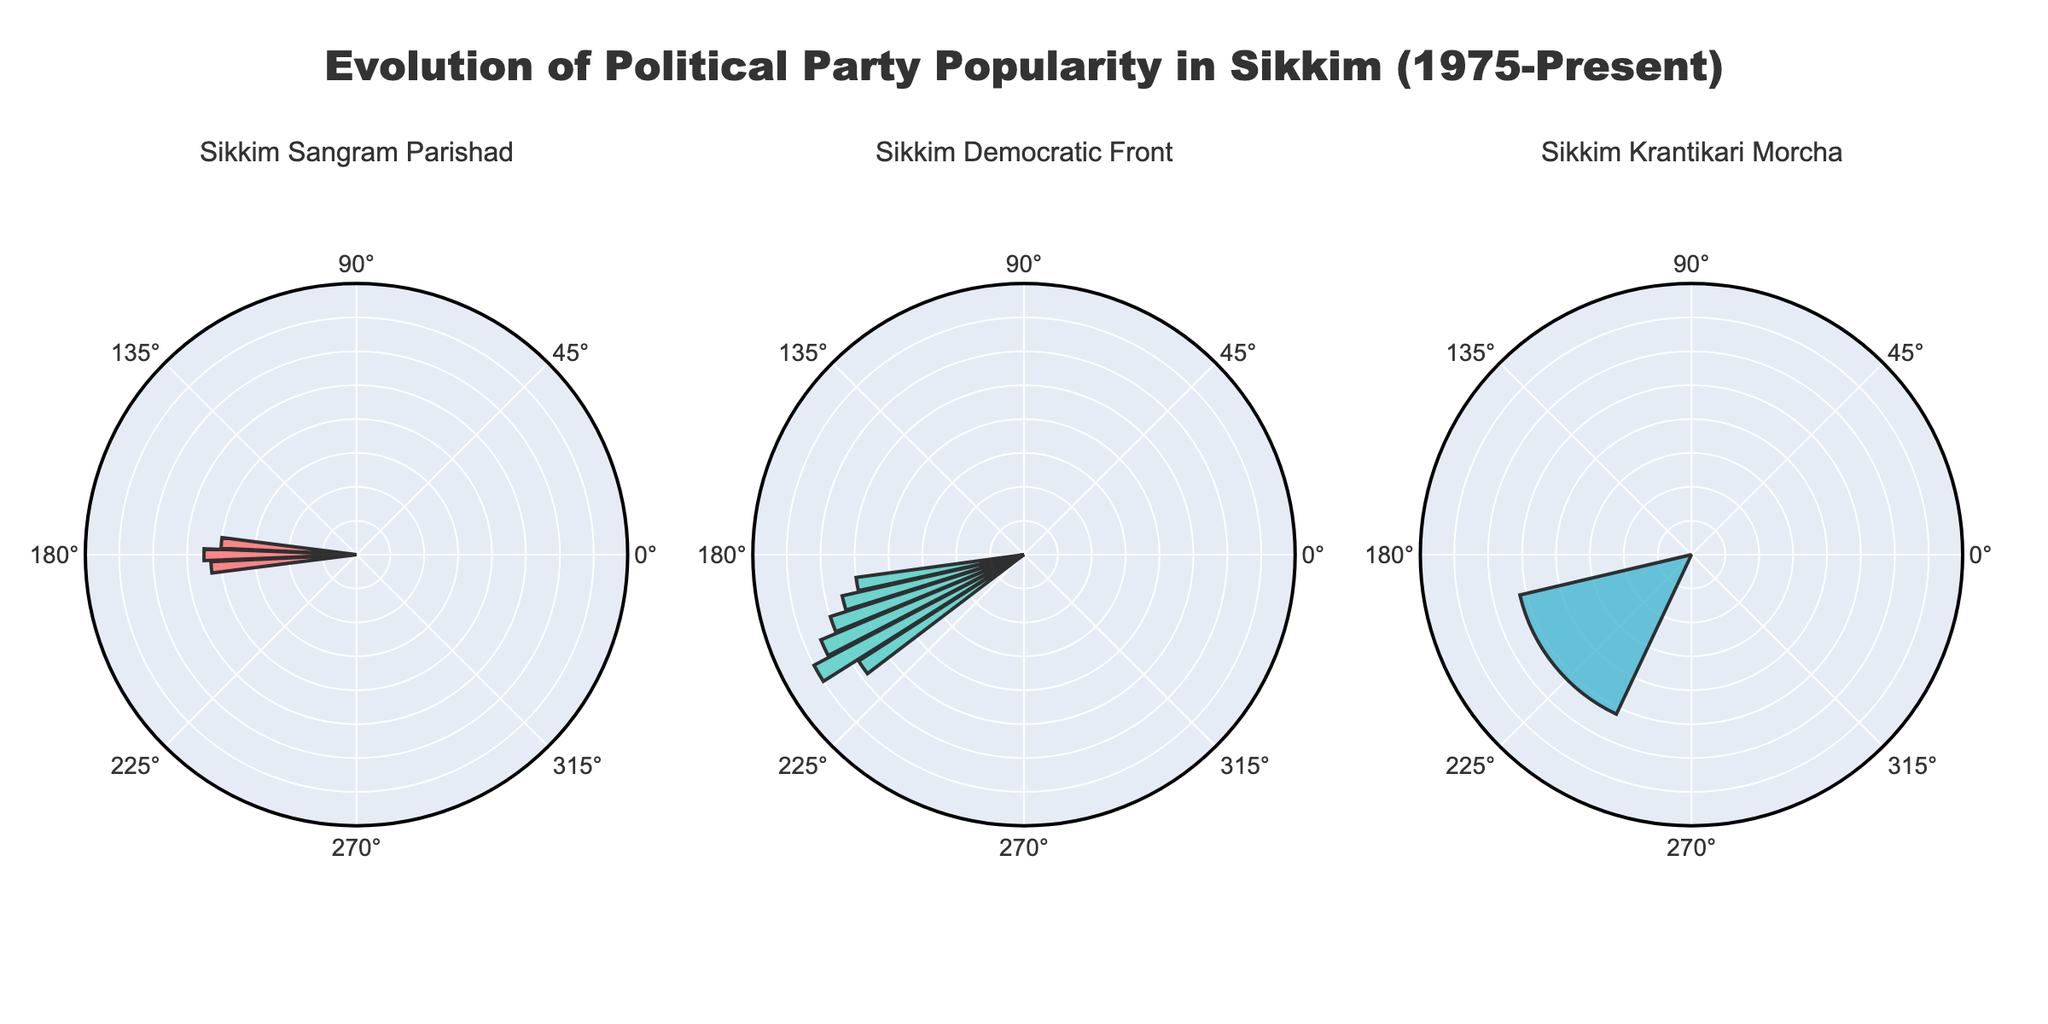What is the title of the figure? The title is prominently displayed at the top of the figure and reads "Evolution of Political Party Popularity in Sikkim (1975-Present)".
Answer: Evolution of Political Party Popularity in Sikkim (1975-Present) Which political party shows the highest popularity over the years? By visually inspecting the polar subplots, we can see that the Sikkim Democratic Front has the highest popularity, peaking at around 70 in 2010.
Answer: Sikkim Democratic Front How many data points are there for the Sikkim Sangram Parishad? Counting the number of bars in the rose chart for the Sikkim Sangram Parishad subplot, we see that there are three data points: 1975, 1980, and 1985.
Answer: 3 What is the average popularity of the Sikkim Democratic Front from 1990 to 2015? Sum the popularity values for the years 1990, 1995, 2000, 2005, and 2010: 50 + 55 + 60 + 65 + 70 = 300. Divide by the number of data points, which is 5.
Answer: 60 Which years show a decline in popularity for the Sikkim Democratic Front? By examining the Sikkim Democratic Front subplot, we see that the popularity decreases between the years 2010 (70) and 2015 (58).
Answer: 2010 to 2015 Compare the popularity of the Sikkim Krantikari Morcha in 2019 to the Sikkim Democratic Front in 2015. Which is higher? The Sikkim Krantikari Morcha has a popularity of 52 in 2019, while the Sikkim Democratic Front has a popularity of 58 in 2015.
Answer: Sikkim Democratic Front in 2015 What is the overall range of popularity values depicted in the figure? The minimum popularity value is 40 (Sikkim Sangram Parishad in 1975), and the maximum is 70 (Sikkim Democratic Front in 2010), resulting in a range of 70 - 40.
Answer: 30 How does the popularity of the Sikkim Democratic Front change from 1990 to 2010? Starting from 50 in 1990, the popularity increases steadily in increments of 5 (50, 55, 60, 65, 70) until 2010.
Answer: It increases every 5 years What is the total number of polar subplots in the figure? Each unique political party has its own polar subplot. Based on the unique party names (Sikkim Sangram Parishad, Sikkim Democratic Front, Sikkim Krantikari Morcha), there are three subplots.
Answer: 3 